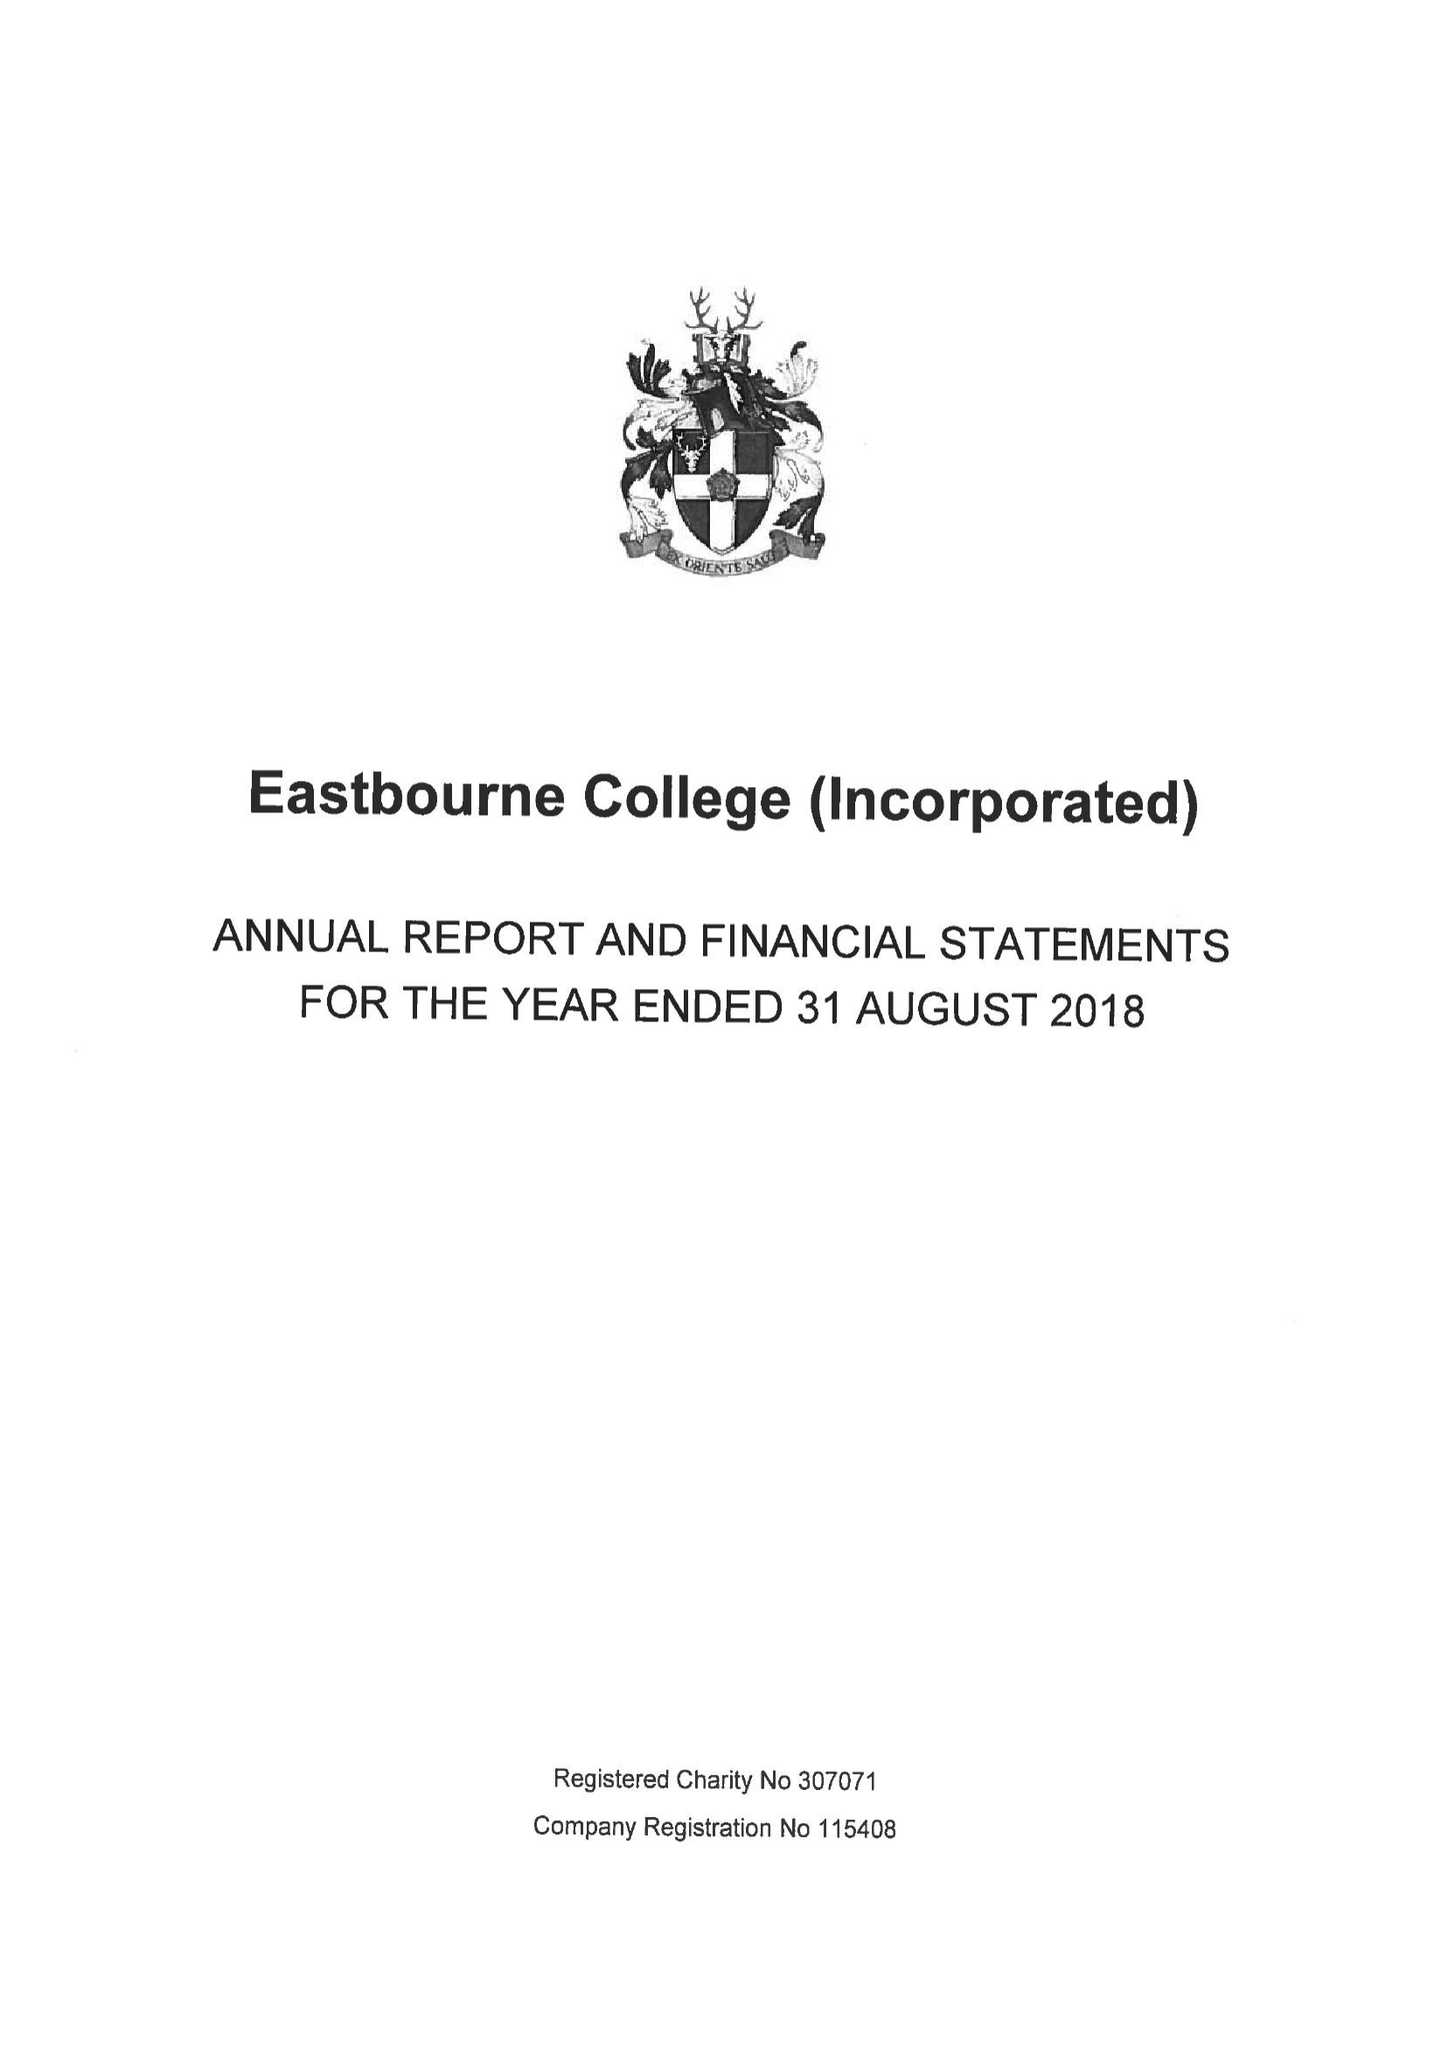What is the value for the address__postcode?
Answer the question using a single word or phrase. BN21 4JY 